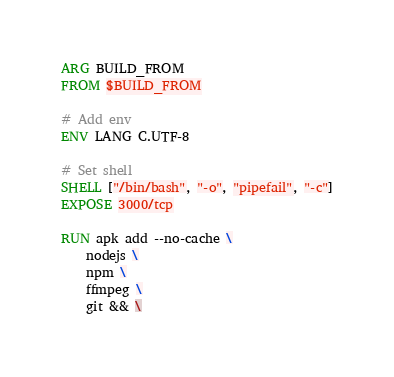<code> <loc_0><loc_0><loc_500><loc_500><_Dockerfile_>ARG BUILD_FROM
FROM $BUILD_FROM

# Add env
ENV LANG C.UTF-8

# Set shell
SHELL ["/bin/bash", "-o", "pipefail", "-c"]
EXPOSE 3000/tcp

RUN apk add --no-cache \
    nodejs \
    npm \
    ffmpeg \
    git && \</code> 